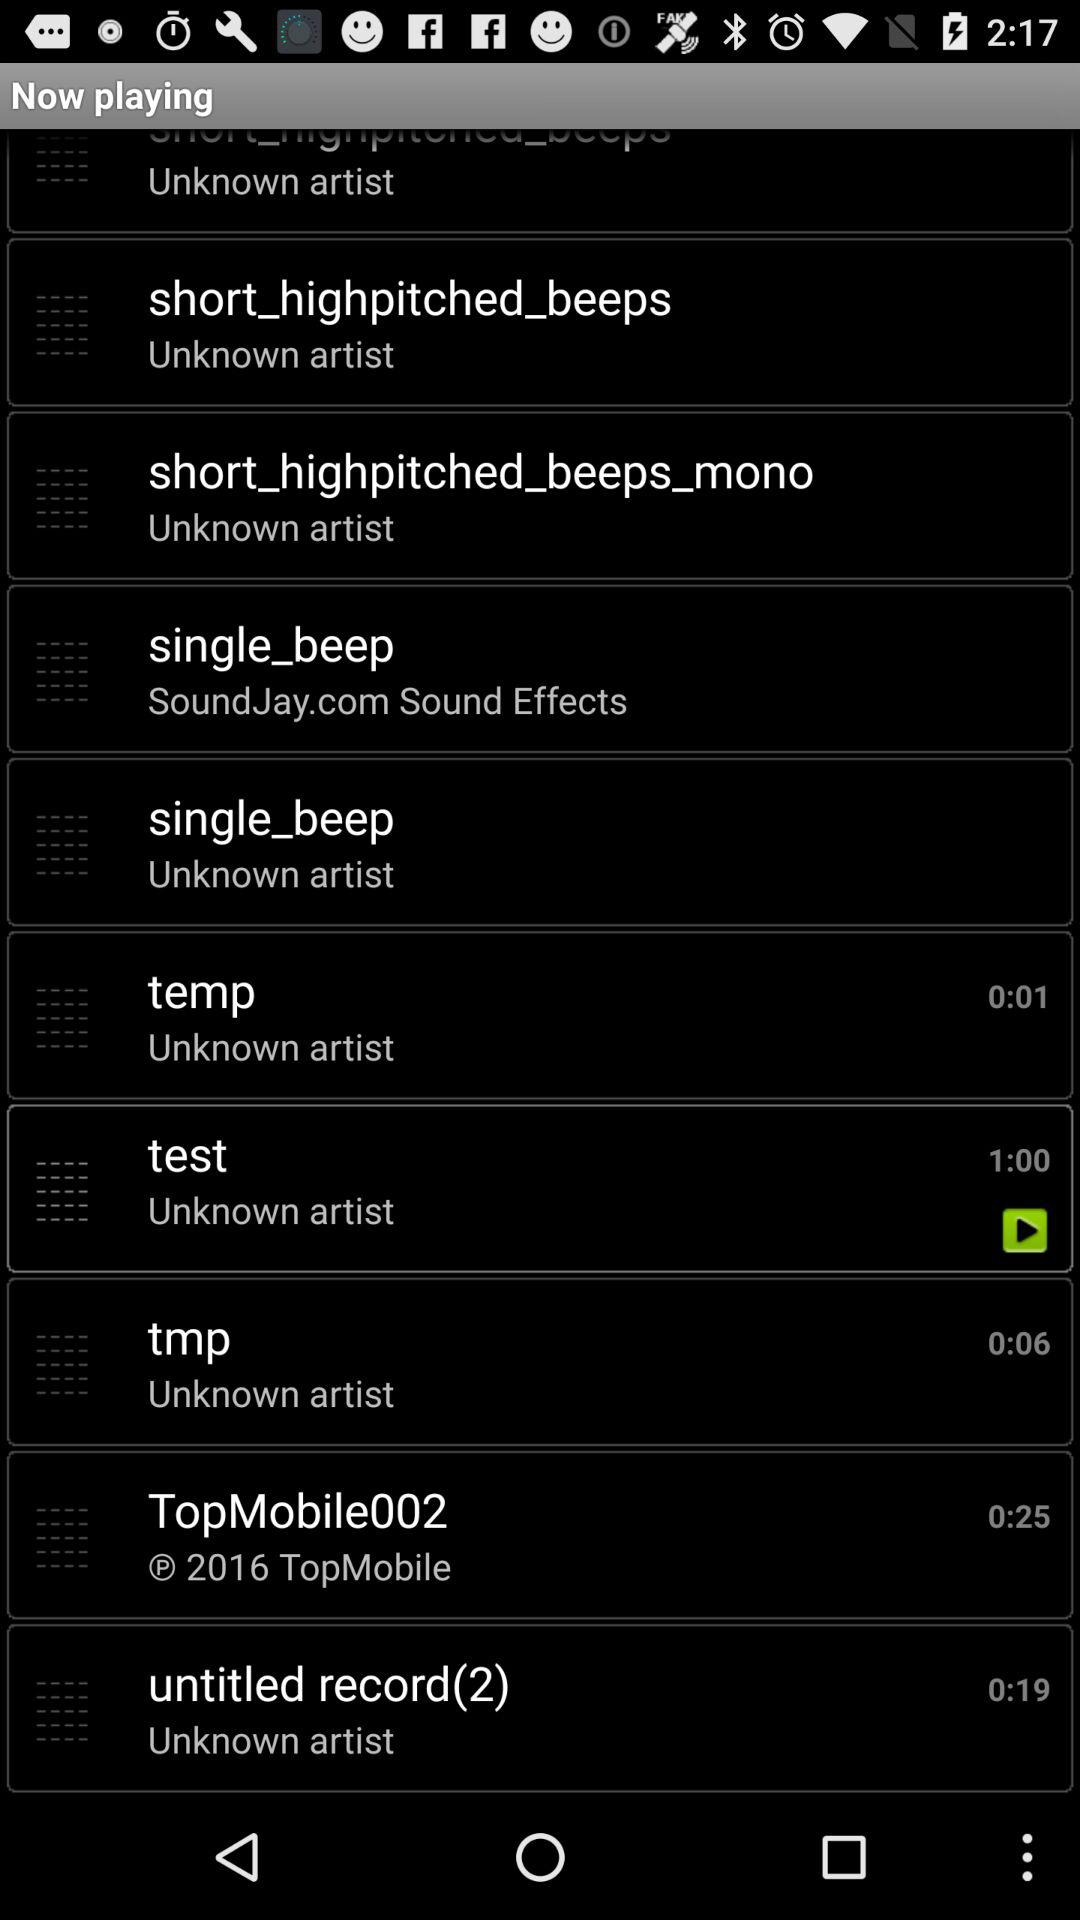Which sound is playing? The sound playing is "test". 